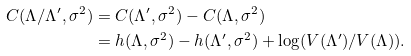Convert formula to latex. <formula><loc_0><loc_0><loc_500><loc_500>C ( \Lambda / \Lambda ^ { \prime } , \sigma ^ { 2 } ) & = C ( \Lambda ^ { \prime } , \sigma ^ { 2 } ) - C ( \Lambda , \sigma ^ { 2 } ) \\ & = h ( \Lambda , \sigma ^ { 2 } ) - h ( \Lambda ^ { \prime } , \sigma ^ { 2 } ) + \log ( V ( \Lambda ^ { \prime } ) / V ( \Lambda ) ) .</formula> 